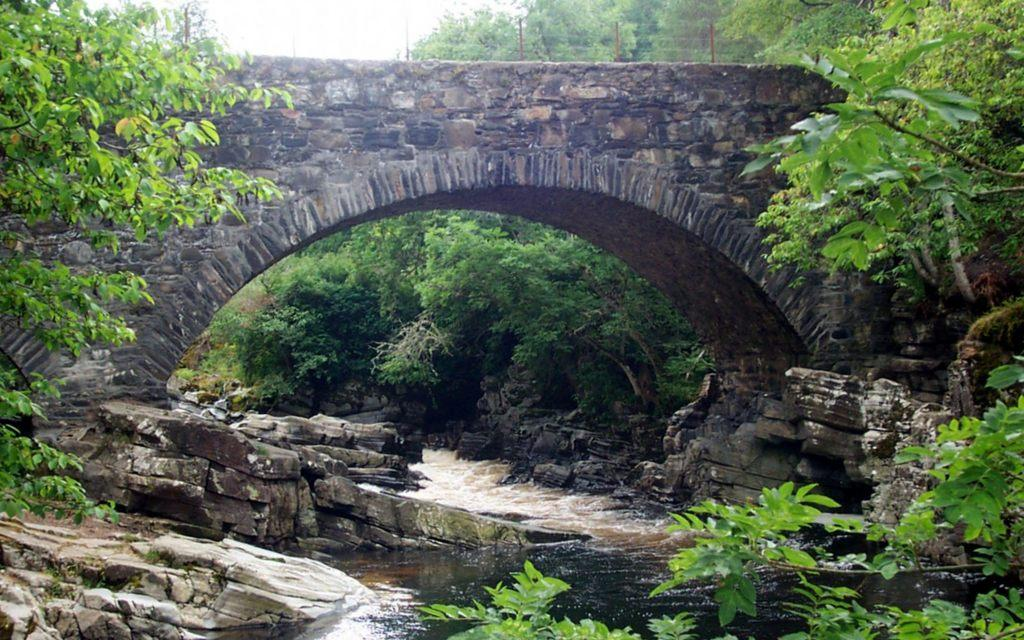What type of natural feature is present in the image? There is a river in the image. How is the river situated in relation to the bridge? The river is under a tunnel bridge. What type of geological features can be seen in the image? Rocks are present in the image. What type of vegetation is visible in the image? Trees and plants are present in the image. What type of construction material is used for the bridge? Iron poles are on the bridge. How would you describe the lighting in the image? The sky is bright in the image. How many eyes can be seen on the rocks in the image? There are no eyes present on the rocks in the image. What type of payment is required to cross the bridge in the image? There is no indication of any payment required to cross the bridge in the image. 